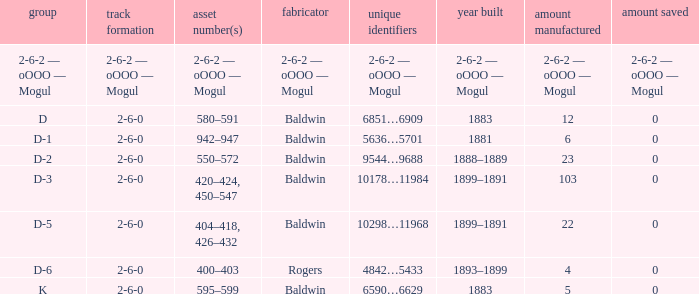What is the quantity made when the wheel arrangement is 2-6-0 and the class is k? 5.0. 